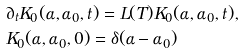<formula> <loc_0><loc_0><loc_500><loc_500>& \partial _ { t } K _ { 0 } ( \alpha , \alpha _ { 0 } , t ) = L ( T ) K _ { 0 } ( \alpha , \alpha _ { 0 } , t ) , \\ & K _ { 0 } ( \alpha , \alpha _ { 0 } , 0 ) = \delta ( \alpha - \alpha _ { 0 } )</formula> 